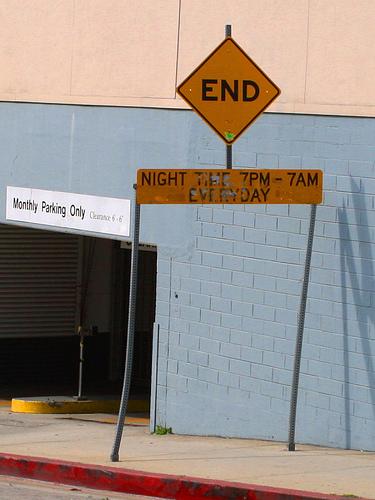Is this a professional event?
Give a very brief answer. No. Is this a parking garage?
Write a very short answer. Yes. What are the times on the sign?
Answer briefly. 7pm-7am. Is parking free?
Give a very brief answer. No. 